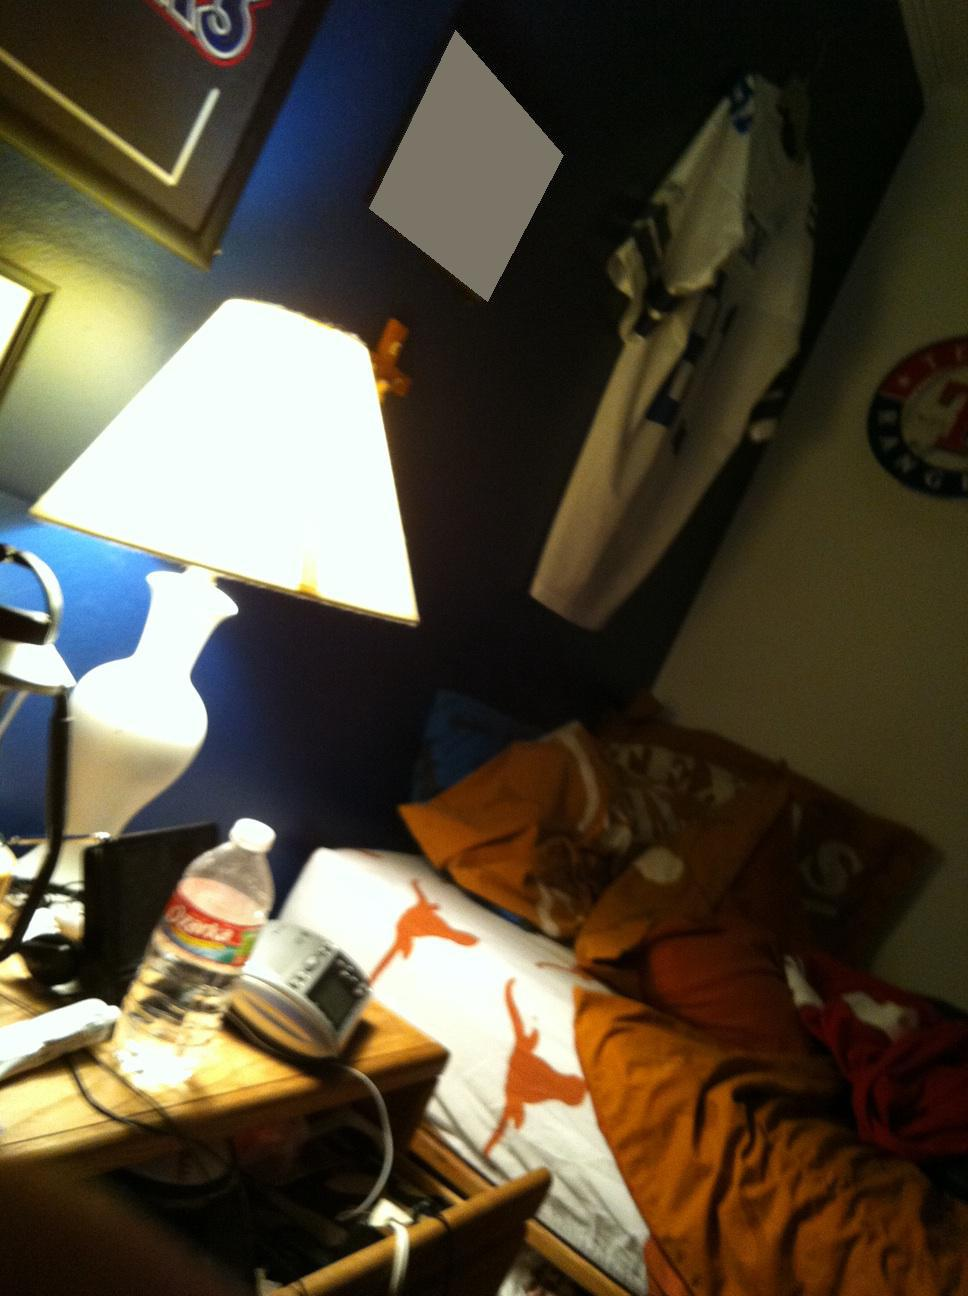What items can you see on the desk? On the desk, there are various items visible including a bottle of Dasani water, a notebook, possibly some electronic devices like a phone or a charger, and a few scattered papers and objects. What does the clutter on the desk suggest about the user? The clutter on the desk suggests that the user might be quite busy or has a lot going on, possibly indicating a student or someone deeply engaged in projects or studying. 